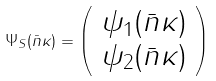Convert formula to latex. <formula><loc_0><loc_0><loc_500><loc_500>\Psi _ { S } ( \bar { n } \kappa ) = \left ( \begin{array} { c } \psi _ { 1 } ( \bar { n } \kappa ) \\ \psi _ { 2 } ( \bar { n } \kappa ) \end{array} \right )</formula> 